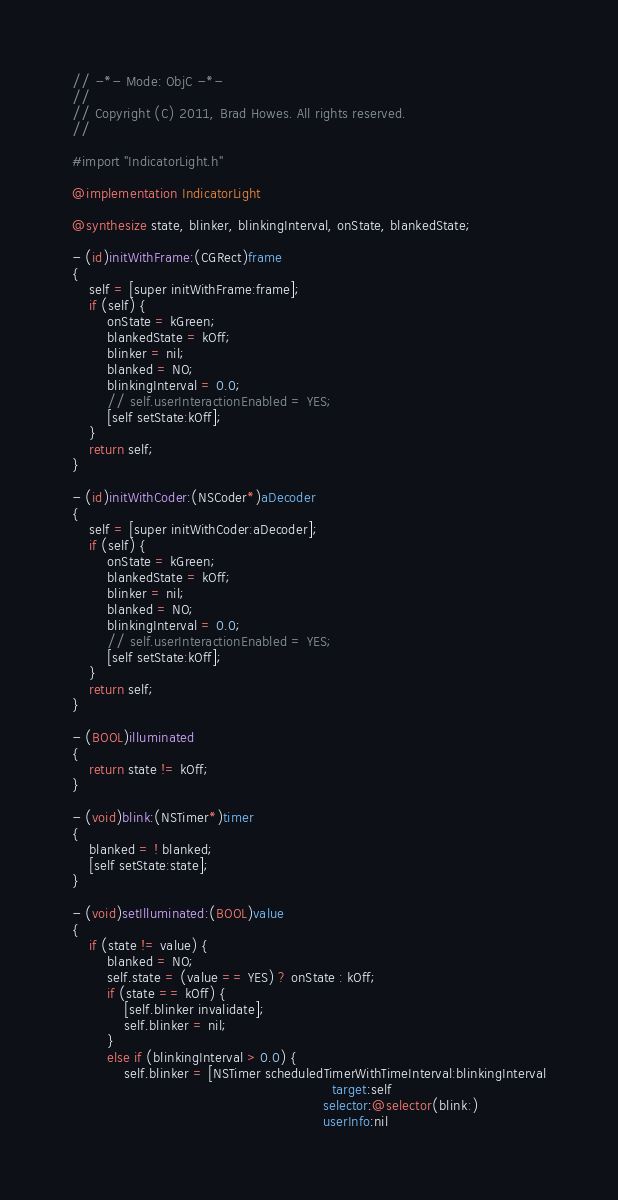<code> <loc_0><loc_0><loc_500><loc_500><_ObjectiveC_>// -*- Mode: ObjC -*-
//
// Copyright (C) 2011, Brad Howes. All rights reserved.
//

#import "IndicatorLight.h"

@implementation IndicatorLight

@synthesize state, blinker, blinkingInterval, onState, blankedState;

- (id)initWithFrame:(CGRect)frame
{
    self = [super initWithFrame:frame];
    if (self) {
        onState = kGreen;
        blankedState = kOff;
        blinker = nil;
        blanked = NO;
        blinkingInterval = 0.0;
        // self.userInteractionEnabled = YES;
        [self setState:kOff];
    }
    return self;
}

- (id)initWithCoder:(NSCoder*)aDecoder
{
    self = [super initWithCoder:aDecoder];
    if (self) {
        onState = kGreen;
        blankedState = kOff;
        blinker = nil;
        blanked = NO;
        blinkingInterval = 0.0;
        // self.userInteractionEnabled = YES;
        [self setState:kOff];
    }
    return self;
}

- (BOOL)illuminated
{
    return state != kOff;
}

- (void)blink:(NSTimer*)timer
{
    blanked = ! blanked;
    [self setState:state];
}

- (void)setIlluminated:(BOOL)value
{
    if (state != value) {
        blanked = NO;
        self.state = (value == YES) ? onState : kOff;
        if (state == kOff) {
            [self.blinker invalidate];
            self.blinker = nil;
        }
        else if (blinkingInterval > 0.0) {
            self.blinker = [NSTimer scheduledTimerWithTimeInterval:blinkingInterval
                                                            target:self
                                                          selector:@selector(blink:)
                                                          userInfo:nil</code> 